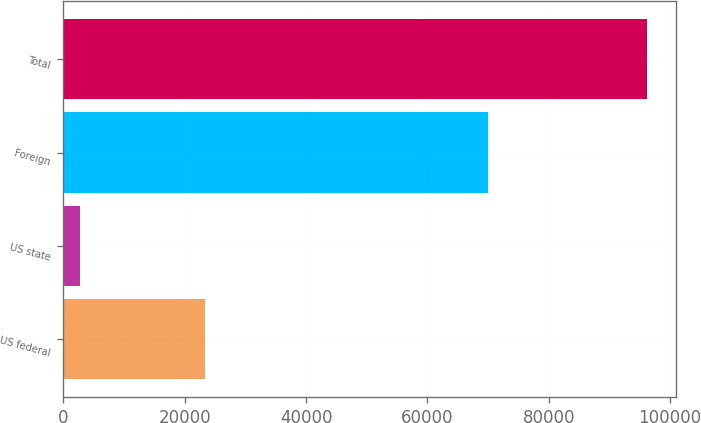Convert chart. <chart><loc_0><loc_0><loc_500><loc_500><bar_chart><fcel>US federal<fcel>US state<fcel>Foreign<fcel>Total<nl><fcel>23412<fcel>2788<fcel>69954<fcel>96154<nl></chart> 